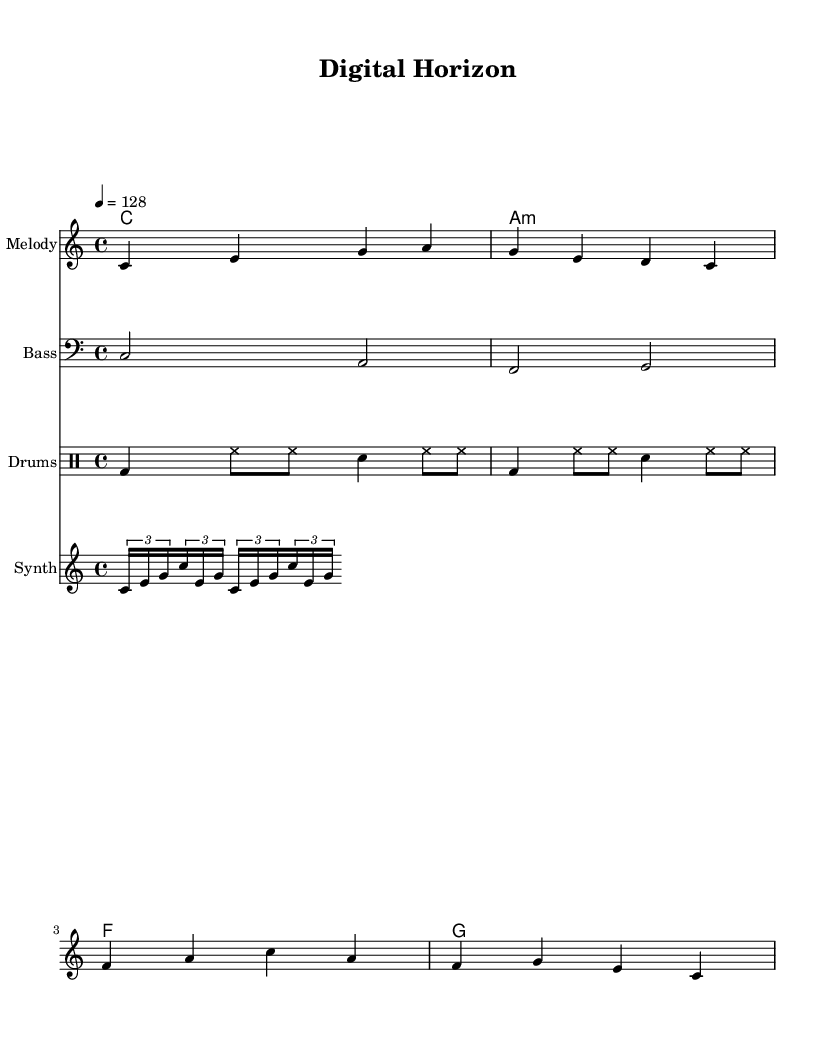What is the key signature of this music? The key signature is C major, which has no sharps or flats.
Answer: C major What is the time signature of the piece? The time signature is specified as 4/4, indicating four beats per measure.
Answer: 4/4 What is the tempo marking for this piece? The tempo marking is 4 equal to 128, denoting the beats per minute.
Answer: 128 How many measures are in the melody? The melody consists of four measures, each separated by a barline.
Answer: 4 Which instruments are featured in this score? The score includes a melody, bass, drums, and synth, each written on a separate staff.
Answer: Melody, Bass, Drums, Synth Which lyrical theme is suggested by the verses? The verses reference digital imagery and neon lights, indicating a tech-inspired theme associated with the futuristic soundscape.
Answer: Digital dreams, neon lights What type of rhythm pattern does the drum follow? The drum pattern features a combination of bass drum, hi-hat, and snare in a consistent rhythmic cycle.
Answer: Bass-HiHat-Snare 